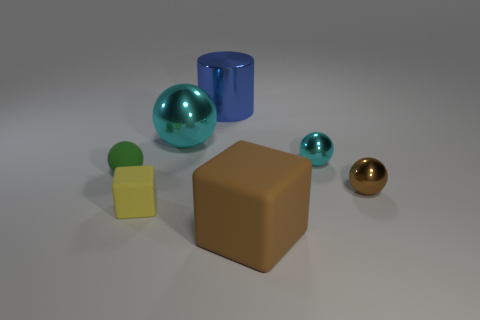Add 1 yellow rubber cylinders. How many objects exist? 8 Subtract all balls. How many objects are left? 3 Subtract 1 yellow cubes. How many objects are left? 6 Subtract all large red metal cubes. Subtract all big cyan balls. How many objects are left? 6 Add 2 small things. How many small things are left? 6 Add 3 tiny cyan rubber objects. How many tiny cyan rubber objects exist? 3 